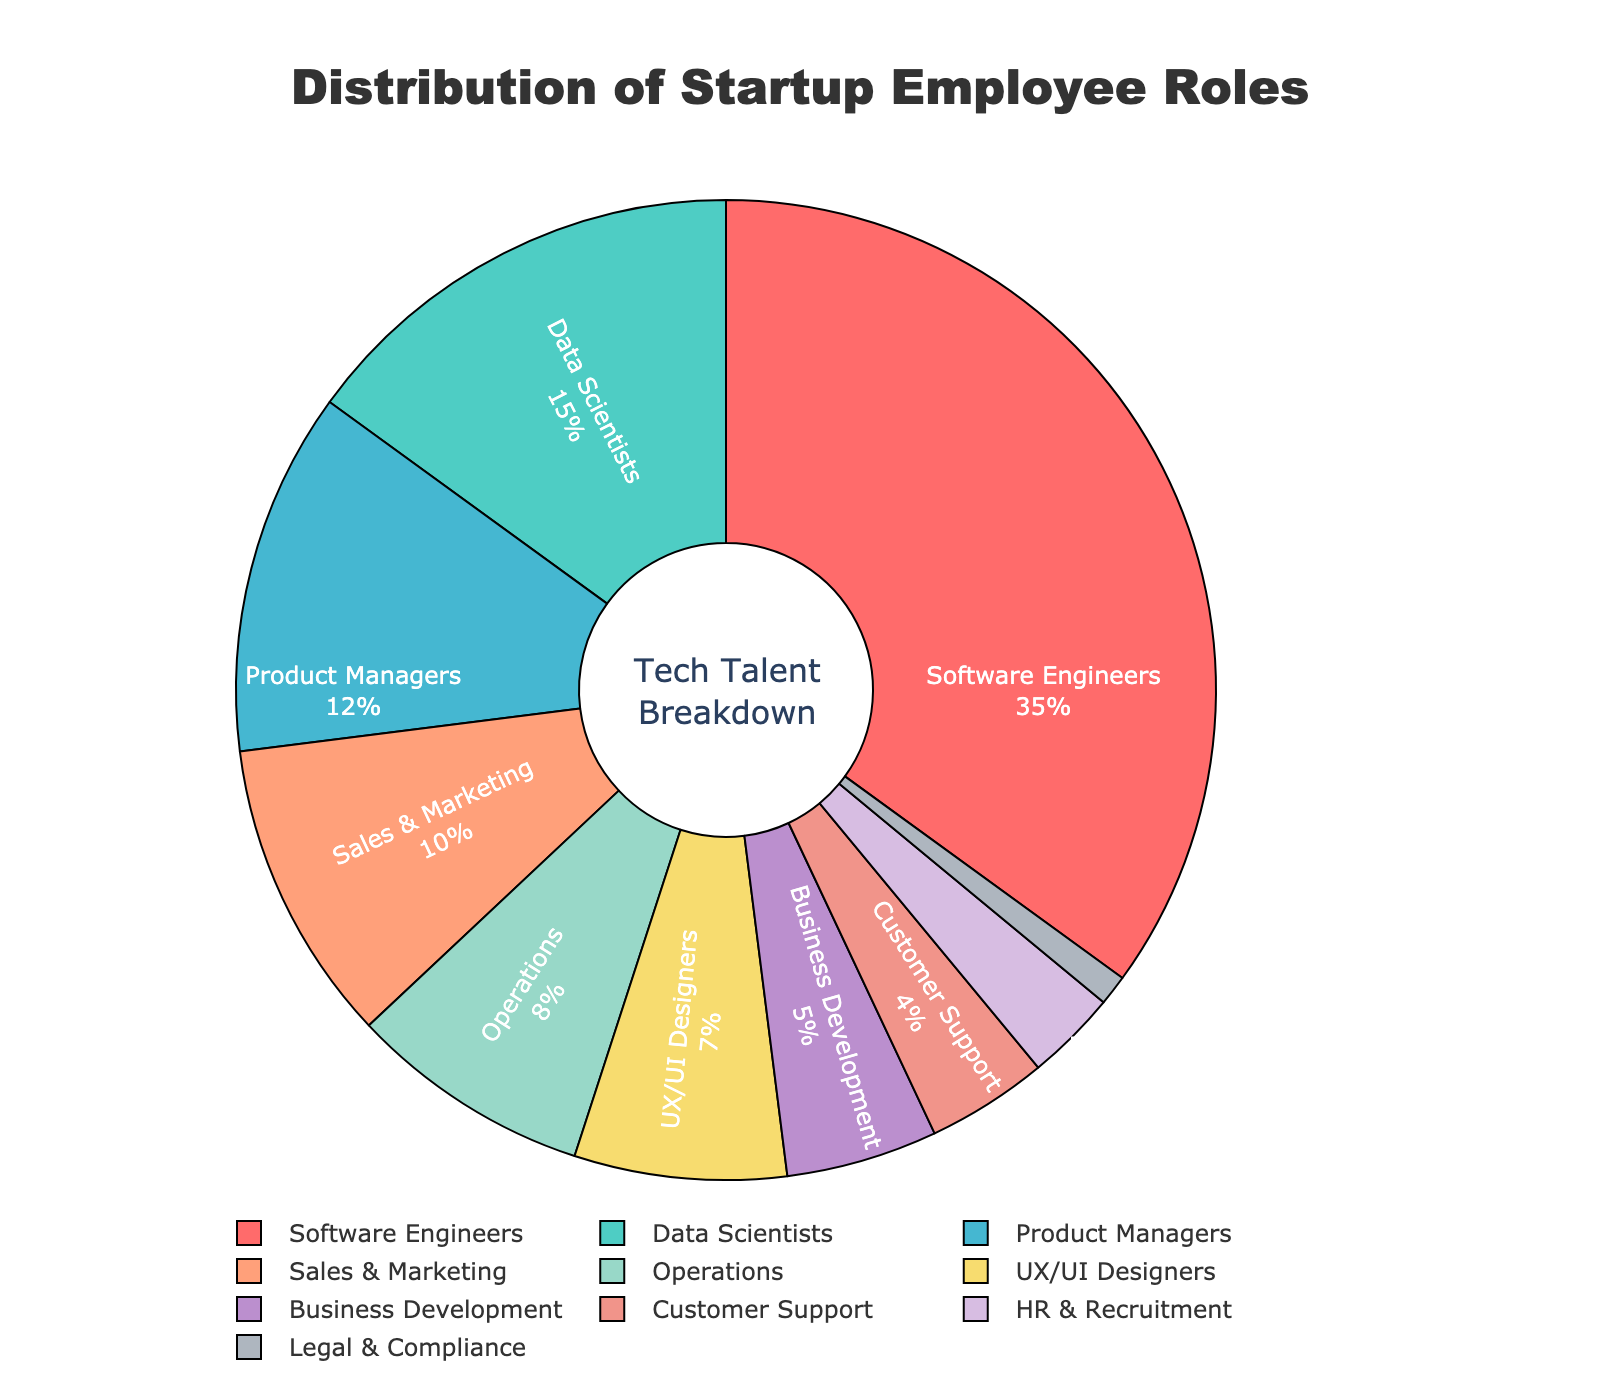What is the percentage of Software Engineers in the startup? Refer to the slice labeled "Software Engineers" in the pie chart. The percentage value associated with this slice is 35%.
Answer: 35% Which role has the smallest percentage, and what is that percentage? Look for the smallest slice in the pie chart and check the label. The smallest slice is labeled "Legal & Compliance" with a percentage of 1%.
Answer: Legal & Compliance, 1% How much more prevalent are Software Engineers compared to Data Scientists? Subtract the percentage of Data Scientists from the percentage of Software Engineers. Software Engineers are 35% and Data Scientists are 15%, so 35% - 15% equals 20%.
Answer: 20% What is the total percentage of employees in Sales & Marketing, Operations, and HR & Recruitment? Sum the percentages of Sales & Marketing (10%), Operations (8%), and HR & Recruitment (3%). 10% + 8% + 3% equals 21%.
Answer: 21% Are there more Business Development employees than Customer Support employees? Look at the sizes and labels of the slices corresponding to Business Development (5%) and Customer Support (4%). Business Development has a higher percentage.
Answer: Yes What two roles have a combined percentage that equal the percentage of Software Engineers? Identify pairs of roles whose percentages add up to 35%. For example, Data Scientists (15%) and Sales & Marketing (10%) combined with UX/UI Designers (7%) equal 35%.
Answer: Data Scientists, Sales & Marketing, and UX/UI Designers Which slice represents roles related to user experience, and what color is it? The role related to user experience is "UX/UI Designers." The slice for UX/UI Designers is visually identifiable by its color in the chart, which is green.
Answer: UX/UI Designers, green By how much does the percentage of Product Managers exceed the percentage of Business Development? Subtract the percentage of Business Development (5%) from Product Managers (12%). 12% - 5% equals 7%.
Answer: 7% Which role represents about one-tenth of the total employee distribution? Identify the slice labeled as 10% in the pie chart, which is "Sales & Marketing."
Answer: Sales & Marketing Is there any role that has more than twice the percentage of Operations? If so, which one? Operations has a percentage of 8%. Identify any role that has more than 16% (double of 8%). Software Engineers at 35% meet this criterion.
Answer: Software Engineers 